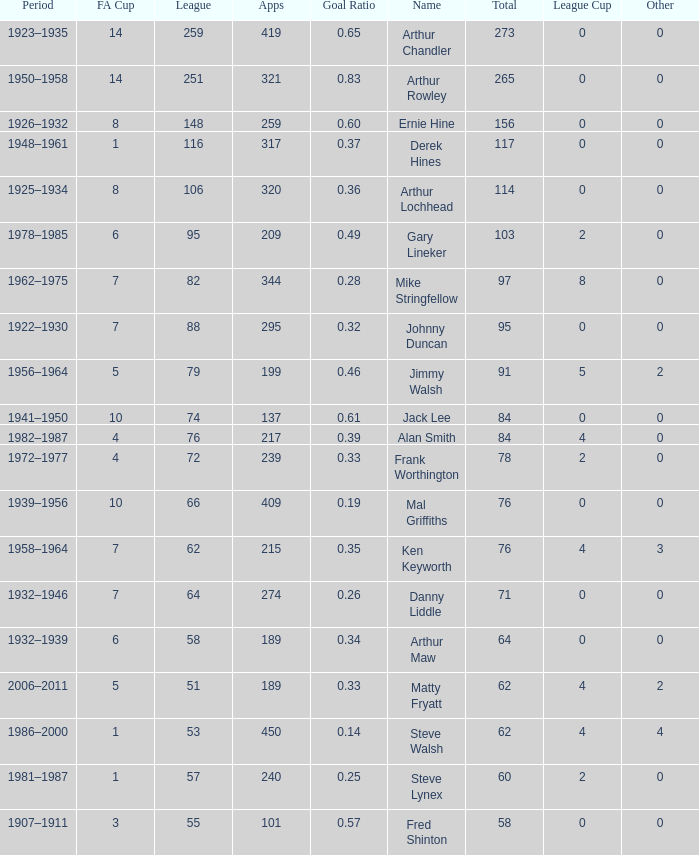What's the Highest Goal Ratio with a League of 88 and an FA Cup less than 7? None. 